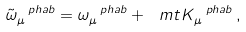<formula> <loc_0><loc_0><loc_500><loc_500>\tilde { \omega } _ { \mu } ^ { \ p h a b } = \omega _ { \mu } ^ { \ p h a b } + \ m t { K } _ { \mu } ^ { \ p h a b } \, ,</formula> 